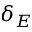<formula> <loc_0><loc_0><loc_500><loc_500>\delta _ { E }</formula> 